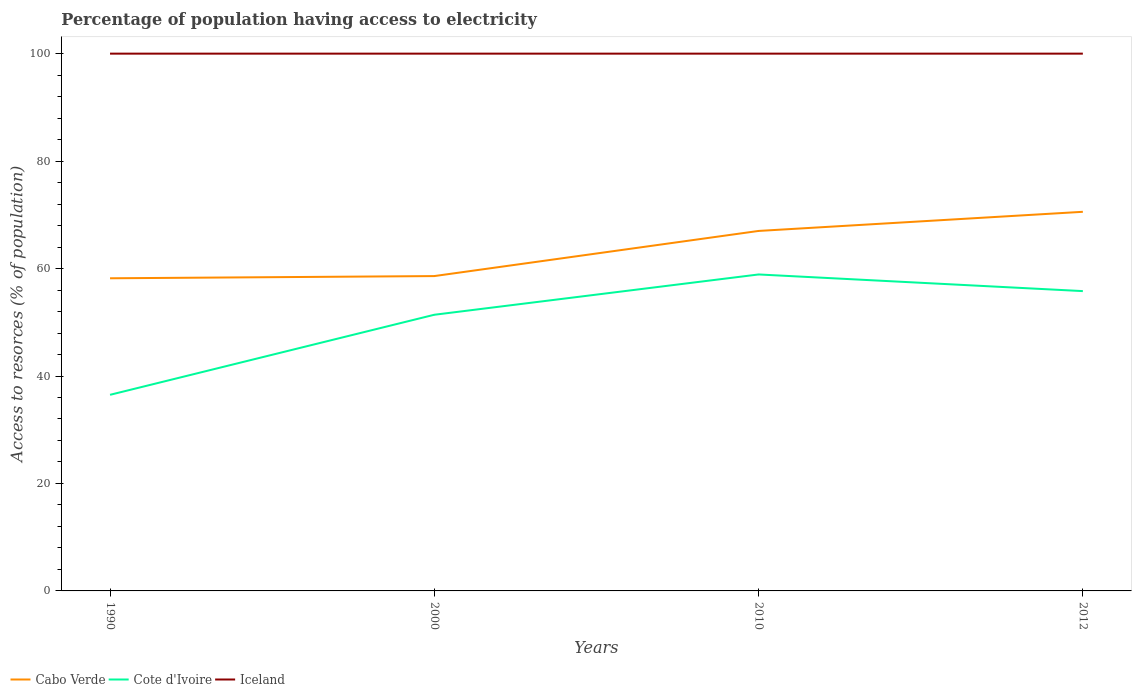How many different coloured lines are there?
Your answer should be very brief. 3. Across all years, what is the maximum percentage of population having access to electricity in Iceland?
Make the answer very short. 100. In which year was the percentage of population having access to electricity in Cabo Verde maximum?
Give a very brief answer. 1990. What is the difference between the highest and the second highest percentage of population having access to electricity in Cote d'Ivoire?
Give a very brief answer. 22.4. What is the difference between the highest and the lowest percentage of population having access to electricity in Cabo Verde?
Your answer should be compact. 2. Is the percentage of population having access to electricity in Cabo Verde strictly greater than the percentage of population having access to electricity in Cote d'Ivoire over the years?
Make the answer very short. No. How many years are there in the graph?
Provide a succinct answer. 4. What is the difference between two consecutive major ticks on the Y-axis?
Keep it short and to the point. 20. Are the values on the major ticks of Y-axis written in scientific E-notation?
Provide a succinct answer. No. Does the graph contain any zero values?
Offer a terse response. No. Does the graph contain grids?
Make the answer very short. No. Where does the legend appear in the graph?
Provide a succinct answer. Bottom left. How many legend labels are there?
Offer a very short reply. 3. How are the legend labels stacked?
Offer a very short reply. Horizontal. What is the title of the graph?
Your answer should be very brief. Percentage of population having access to electricity. What is the label or title of the Y-axis?
Provide a short and direct response. Access to resorces (% of population). What is the Access to resorces (% of population) of Cabo Verde in 1990?
Your answer should be very brief. 58.19. What is the Access to resorces (% of population) of Cote d'Ivoire in 1990?
Ensure brevity in your answer.  36.5. What is the Access to resorces (% of population) of Iceland in 1990?
Give a very brief answer. 100. What is the Access to resorces (% of population) in Cabo Verde in 2000?
Keep it short and to the point. 58.6. What is the Access to resorces (% of population) of Cote d'Ivoire in 2000?
Your answer should be very brief. 51.4. What is the Access to resorces (% of population) of Iceland in 2000?
Offer a very short reply. 100. What is the Access to resorces (% of population) in Cabo Verde in 2010?
Keep it short and to the point. 67. What is the Access to resorces (% of population) of Cote d'Ivoire in 2010?
Ensure brevity in your answer.  58.9. What is the Access to resorces (% of population) of Cabo Verde in 2012?
Make the answer very short. 70.56. What is the Access to resorces (% of population) of Cote d'Ivoire in 2012?
Your response must be concise. 55.8. Across all years, what is the maximum Access to resorces (% of population) in Cabo Verde?
Keep it short and to the point. 70.56. Across all years, what is the maximum Access to resorces (% of population) of Cote d'Ivoire?
Your response must be concise. 58.9. Across all years, what is the maximum Access to resorces (% of population) in Iceland?
Offer a very short reply. 100. Across all years, what is the minimum Access to resorces (% of population) of Cabo Verde?
Keep it short and to the point. 58.19. Across all years, what is the minimum Access to resorces (% of population) of Cote d'Ivoire?
Keep it short and to the point. 36.5. What is the total Access to resorces (% of population) of Cabo Verde in the graph?
Provide a short and direct response. 254.35. What is the total Access to resorces (% of population) of Cote d'Ivoire in the graph?
Offer a terse response. 202.6. What is the total Access to resorces (% of population) in Iceland in the graph?
Your answer should be very brief. 400. What is the difference between the Access to resorces (% of population) in Cabo Verde in 1990 and that in 2000?
Offer a terse response. -0.41. What is the difference between the Access to resorces (% of population) in Cote d'Ivoire in 1990 and that in 2000?
Your answer should be compact. -14.9. What is the difference between the Access to resorces (% of population) of Iceland in 1990 and that in 2000?
Ensure brevity in your answer.  0. What is the difference between the Access to resorces (% of population) in Cabo Verde in 1990 and that in 2010?
Offer a terse response. -8.81. What is the difference between the Access to resorces (% of population) in Cote d'Ivoire in 1990 and that in 2010?
Your response must be concise. -22.4. What is the difference between the Access to resorces (% of population) in Iceland in 1990 and that in 2010?
Provide a short and direct response. 0. What is the difference between the Access to resorces (% of population) in Cabo Verde in 1990 and that in 2012?
Provide a short and direct response. -12.37. What is the difference between the Access to resorces (% of population) in Cote d'Ivoire in 1990 and that in 2012?
Give a very brief answer. -19.3. What is the difference between the Access to resorces (% of population) of Iceland in 1990 and that in 2012?
Provide a succinct answer. 0. What is the difference between the Access to resorces (% of population) of Cabo Verde in 2000 and that in 2010?
Your answer should be very brief. -8.4. What is the difference between the Access to resorces (% of population) of Cabo Verde in 2000 and that in 2012?
Make the answer very short. -11.96. What is the difference between the Access to resorces (% of population) in Cote d'Ivoire in 2000 and that in 2012?
Offer a terse response. -4.4. What is the difference between the Access to resorces (% of population) of Iceland in 2000 and that in 2012?
Give a very brief answer. 0. What is the difference between the Access to resorces (% of population) of Cabo Verde in 2010 and that in 2012?
Give a very brief answer. -3.56. What is the difference between the Access to resorces (% of population) of Cote d'Ivoire in 2010 and that in 2012?
Your answer should be very brief. 3.1. What is the difference between the Access to resorces (% of population) in Cabo Verde in 1990 and the Access to resorces (% of population) in Cote d'Ivoire in 2000?
Offer a terse response. 6.79. What is the difference between the Access to resorces (% of population) in Cabo Verde in 1990 and the Access to resorces (% of population) in Iceland in 2000?
Your answer should be compact. -41.81. What is the difference between the Access to resorces (% of population) of Cote d'Ivoire in 1990 and the Access to resorces (% of population) of Iceland in 2000?
Make the answer very short. -63.5. What is the difference between the Access to resorces (% of population) in Cabo Verde in 1990 and the Access to resorces (% of population) in Cote d'Ivoire in 2010?
Ensure brevity in your answer.  -0.71. What is the difference between the Access to resorces (% of population) of Cabo Verde in 1990 and the Access to resorces (% of population) of Iceland in 2010?
Make the answer very short. -41.81. What is the difference between the Access to resorces (% of population) in Cote d'Ivoire in 1990 and the Access to resorces (% of population) in Iceland in 2010?
Provide a succinct answer. -63.5. What is the difference between the Access to resorces (% of population) in Cabo Verde in 1990 and the Access to resorces (% of population) in Cote d'Ivoire in 2012?
Offer a terse response. 2.39. What is the difference between the Access to resorces (% of population) of Cabo Verde in 1990 and the Access to resorces (% of population) of Iceland in 2012?
Your response must be concise. -41.81. What is the difference between the Access to resorces (% of population) of Cote d'Ivoire in 1990 and the Access to resorces (% of population) of Iceland in 2012?
Keep it short and to the point. -63.5. What is the difference between the Access to resorces (% of population) in Cabo Verde in 2000 and the Access to resorces (% of population) in Cote d'Ivoire in 2010?
Your response must be concise. -0.3. What is the difference between the Access to resorces (% of population) of Cabo Verde in 2000 and the Access to resorces (% of population) of Iceland in 2010?
Keep it short and to the point. -41.4. What is the difference between the Access to resorces (% of population) in Cote d'Ivoire in 2000 and the Access to resorces (% of population) in Iceland in 2010?
Ensure brevity in your answer.  -48.6. What is the difference between the Access to resorces (% of population) of Cabo Verde in 2000 and the Access to resorces (% of population) of Iceland in 2012?
Provide a succinct answer. -41.4. What is the difference between the Access to resorces (% of population) of Cote d'Ivoire in 2000 and the Access to resorces (% of population) of Iceland in 2012?
Provide a short and direct response. -48.6. What is the difference between the Access to resorces (% of population) in Cabo Verde in 2010 and the Access to resorces (% of population) in Iceland in 2012?
Provide a short and direct response. -33. What is the difference between the Access to resorces (% of population) in Cote d'Ivoire in 2010 and the Access to resorces (% of population) in Iceland in 2012?
Ensure brevity in your answer.  -41.1. What is the average Access to resorces (% of population) in Cabo Verde per year?
Offer a terse response. 63.59. What is the average Access to resorces (% of population) of Cote d'Ivoire per year?
Ensure brevity in your answer.  50.65. In the year 1990, what is the difference between the Access to resorces (% of population) of Cabo Verde and Access to resorces (% of population) of Cote d'Ivoire?
Keep it short and to the point. 21.69. In the year 1990, what is the difference between the Access to resorces (% of population) of Cabo Verde and Access to resorces (% of population) of Iceland?
Make the answer very short. -41.81. In the year 1990, what is the difference between the Access to resorces (% of population) in Cote d'Ivoire and Access to resorces (% of population) in Iceland?
Offer a very short reply. -63.5. In the year 2000, what is the difference between the Access to resorces (% of population) of Cabo Verde and Access to resorces (% of population) of Cote d'Ivoire?
Make the answer very short. 7.2. In the year 2000, what is the difference between the Access to resorces (% of population) in Cabo Verde and Access to resorces (% of population) in Iceland?
Give a very brief answer. -41.4. In the year 2000, what is the difference between the Access to resorces (% of population) of Cote d'Ivoire and Access to resorces (% of population) of Iceland?
Give a very brief answer. -48.6. In the year 2010, what is the difference between the Access to resorces (% of population) in Cabo Verde and Access to resorces (% of population) in Cote d'Ivoire?
Your answer should be compact. 8.1. In the year 2010, what is the difference between the Access to resorces (% of population) in Cabo Verde and Access to resorces (% of population) in Iceland?
Your answer should be compact. -33. In the year 2010, what is the difference between the Access to resorces (% of population) of Cote d'Ivoire and Access to resorces (% of population) of Iceland?
Ensure brevity in your answer.  -41.1. In the year 2012, what is the difference between the Access to resorces (% of population) of Cabo Verde and Access to resorces (% of population) of Cote d'Ivoire?
Offer a terse response. 14.76. In the year 2012, what is the difference between the Access to resorces (% of population) in Cabo Verde and Access to resorces (% of population) in Iceland?
Provide a short and direct response. -29.44. In the year 2012, what is the difference between the Access to resorces (% of population) of Cote d'Ivoire and Access to resorces (% of population) of Iceland?
Your response must be concise. -44.2. What is the ratio of the Access to resorces (% of population) in Cabo Verde in 1990 to that in 2000?
Offer a terse response. 0.99. What is the ratio of the Access to resorces (% of population) in Cote d'Ivoire in 1990 to that in 2000?
Offer a very short reply. 0.71. What is the ratio of the Access to resorces (% of population) in Iceland in 1990 to that in 2000?
Keep it short and to the point. 1. What is the ratio of the Access to resorces (% of population) of Cabo Verde in 1990 to that in 2010?
Offer a very short reply. 0.87. What is the ratio of the Access to resorces (% of population) of Cote d'Ivoire in 1990 to that in 2010?
Your answer should be compact. 0.62. What is the ratio of the Access to resorces (% of population) in Iceland in 1990 to that in 2010?
Provide a succinct answer. 1. What is the ratio of the Access to resorces (% of population) of Cabo Verde in 1990 to that in 2012?
Offer a terse response. 0.82. What is the ratio of the Access to resorces (% of population) of Cote d'Ivoire in 1990 to that in 2012?
Give a very brief answer. 0.65. What is the ratio of the Access to resorces (% of population) in Iceland in 1990 to that in 2012?
Your answer should be compact. 1. What is the ratio of the Access to resorces (% of population) of Cabo Verde in 2000 to that in 2010?
Provide a succinct answer. 0.87. What is the ratio of the Access to resorces (% of population) in Cote d'Ivoire in 2000 to that in 2010?
Your answer should be very brief. 0.87. What is the ratio of the Access to resorces (% of population) of Iceland in 2000 to that in 2010?
Make the answer very short. 1. What is the ratio of the Access to resorces (% of population) of Cabo Verde in 2000 to that in 2012?
Your answer should be very brief. 0.83. What is the ratio of the Access to resorces (% of population) in Cote d'Ivoire in 2000 to that in 2012?
Ensure brevity in your answer.  0.92. What is the ratio of the Access to resorces (% of population) of Cabo Verde in 2010 to that in 2012?
Offer a terse response. 0.95. What is the ratio of the Access to resorces (% of population) in Cote d'Ivoire in 2010 to that in 2012?
Provide a short and direct response. 1.06. What is the difference between the highest and the second highest Access to resorces (% of population) of Cabo Verde?
Make the answer very short. 3.56. What is the difference between the highest and the lowest Access to resorces (% of population) of Cabo Verde?
Provide a short and direct response. 12.37. What is the difference between the highest and the lowest Access to resorces (% of population) in Cote d'Ivoire?
Provide a succinct answer. 22.4. 